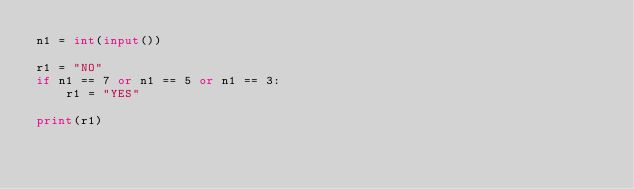<code> <loc_0><loc_0><loc_500><loc_500><_Python_>n1 = int(input())

r1 = "NO"
if n1 == 7 or n1 == 5 or n1 == 3:
    r1 = "YES"

print(r1)
</code> 